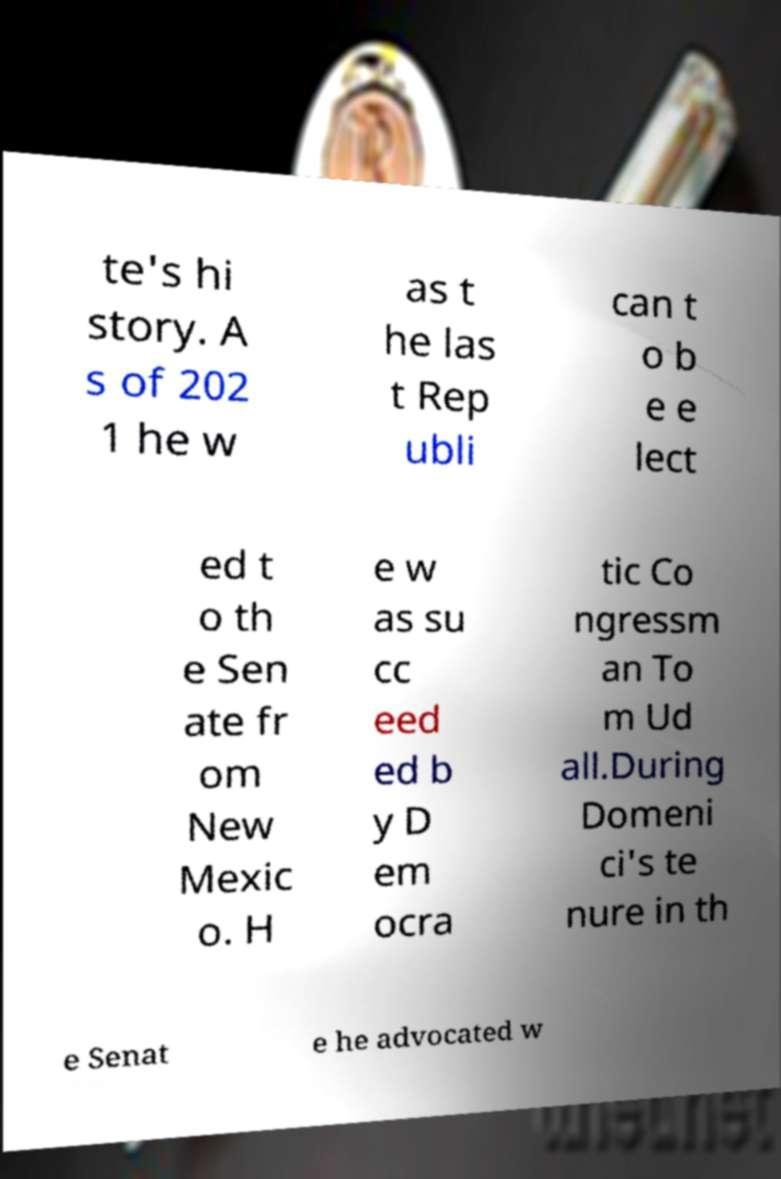Could you assist in decoding the text presented in this image and type it out clearly? te's hi story. A s of 202 1 he w as t he las t Rep ubli can t o b e e lect ed t o th e Sen ate fr om New Mexic o. H e w as su cc eed ed b y D em ocra tic Co ngressm an To m Ud all.During Domeni ci's te nure in th e Senat e he advocated w 